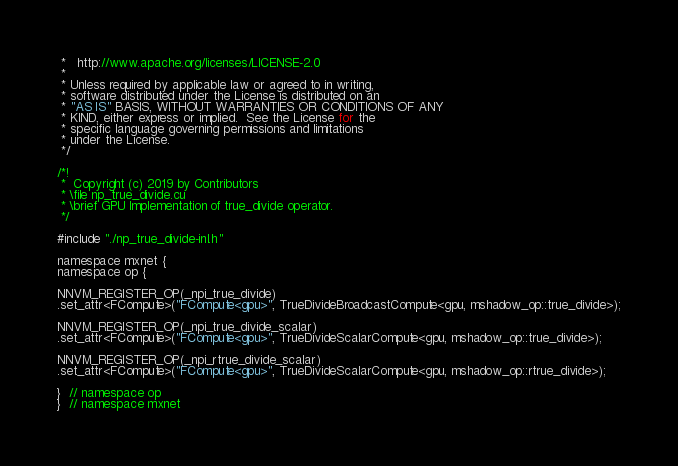<code> <loc_0><loc_0><loc_500><loc_500><_Cuda_> *   http://www.apache.org/licenses/LICENSE-2.0
 *
 * Unless required by applicable law or agreed to in writing,
 * software distributed under the License is distributed on an
 * "AS IS" BASIS, WITHOUT WARRANTIES OR CONDITIONS OF ANY
 * KIND, either express or implied.  See the License for the
 * specific language governing permissions and limitations
 * under the License.
 */

/*!
 *  Copyright (c) 2019 by Contributors
 * \file np_true_divide.cu
 * \brief GPU Implementation of true_divide operator.
 */

#include "./np_true_divide-inl.h"

namespace mxnet {
namespace op {

NNVM_REGISTER_OP(_npi_true_divide)
.set_attr<FCompute>("FCompute<gpu>", TrueDivideBroadcastCompute<gpu, mshadow_op::true_divide>);

NNVM_REGISTER_OP(_npi_true_divide_scalar)
.set_attr<FCompute>("FCompute<gpu>", TrueDivideScalarCompute<gpu, mshadow_op::true_divide>);

NNVM_REGISTER_OP(_npi_rtrue_divide_scalar)
.set_attr<FCompute>("FCompute<gpu>", TrueDivideScalarCompute<gpu, mshadow_op::rtrue_divide>);

}  // namespace op
}  // namespace mxnet
</code> 